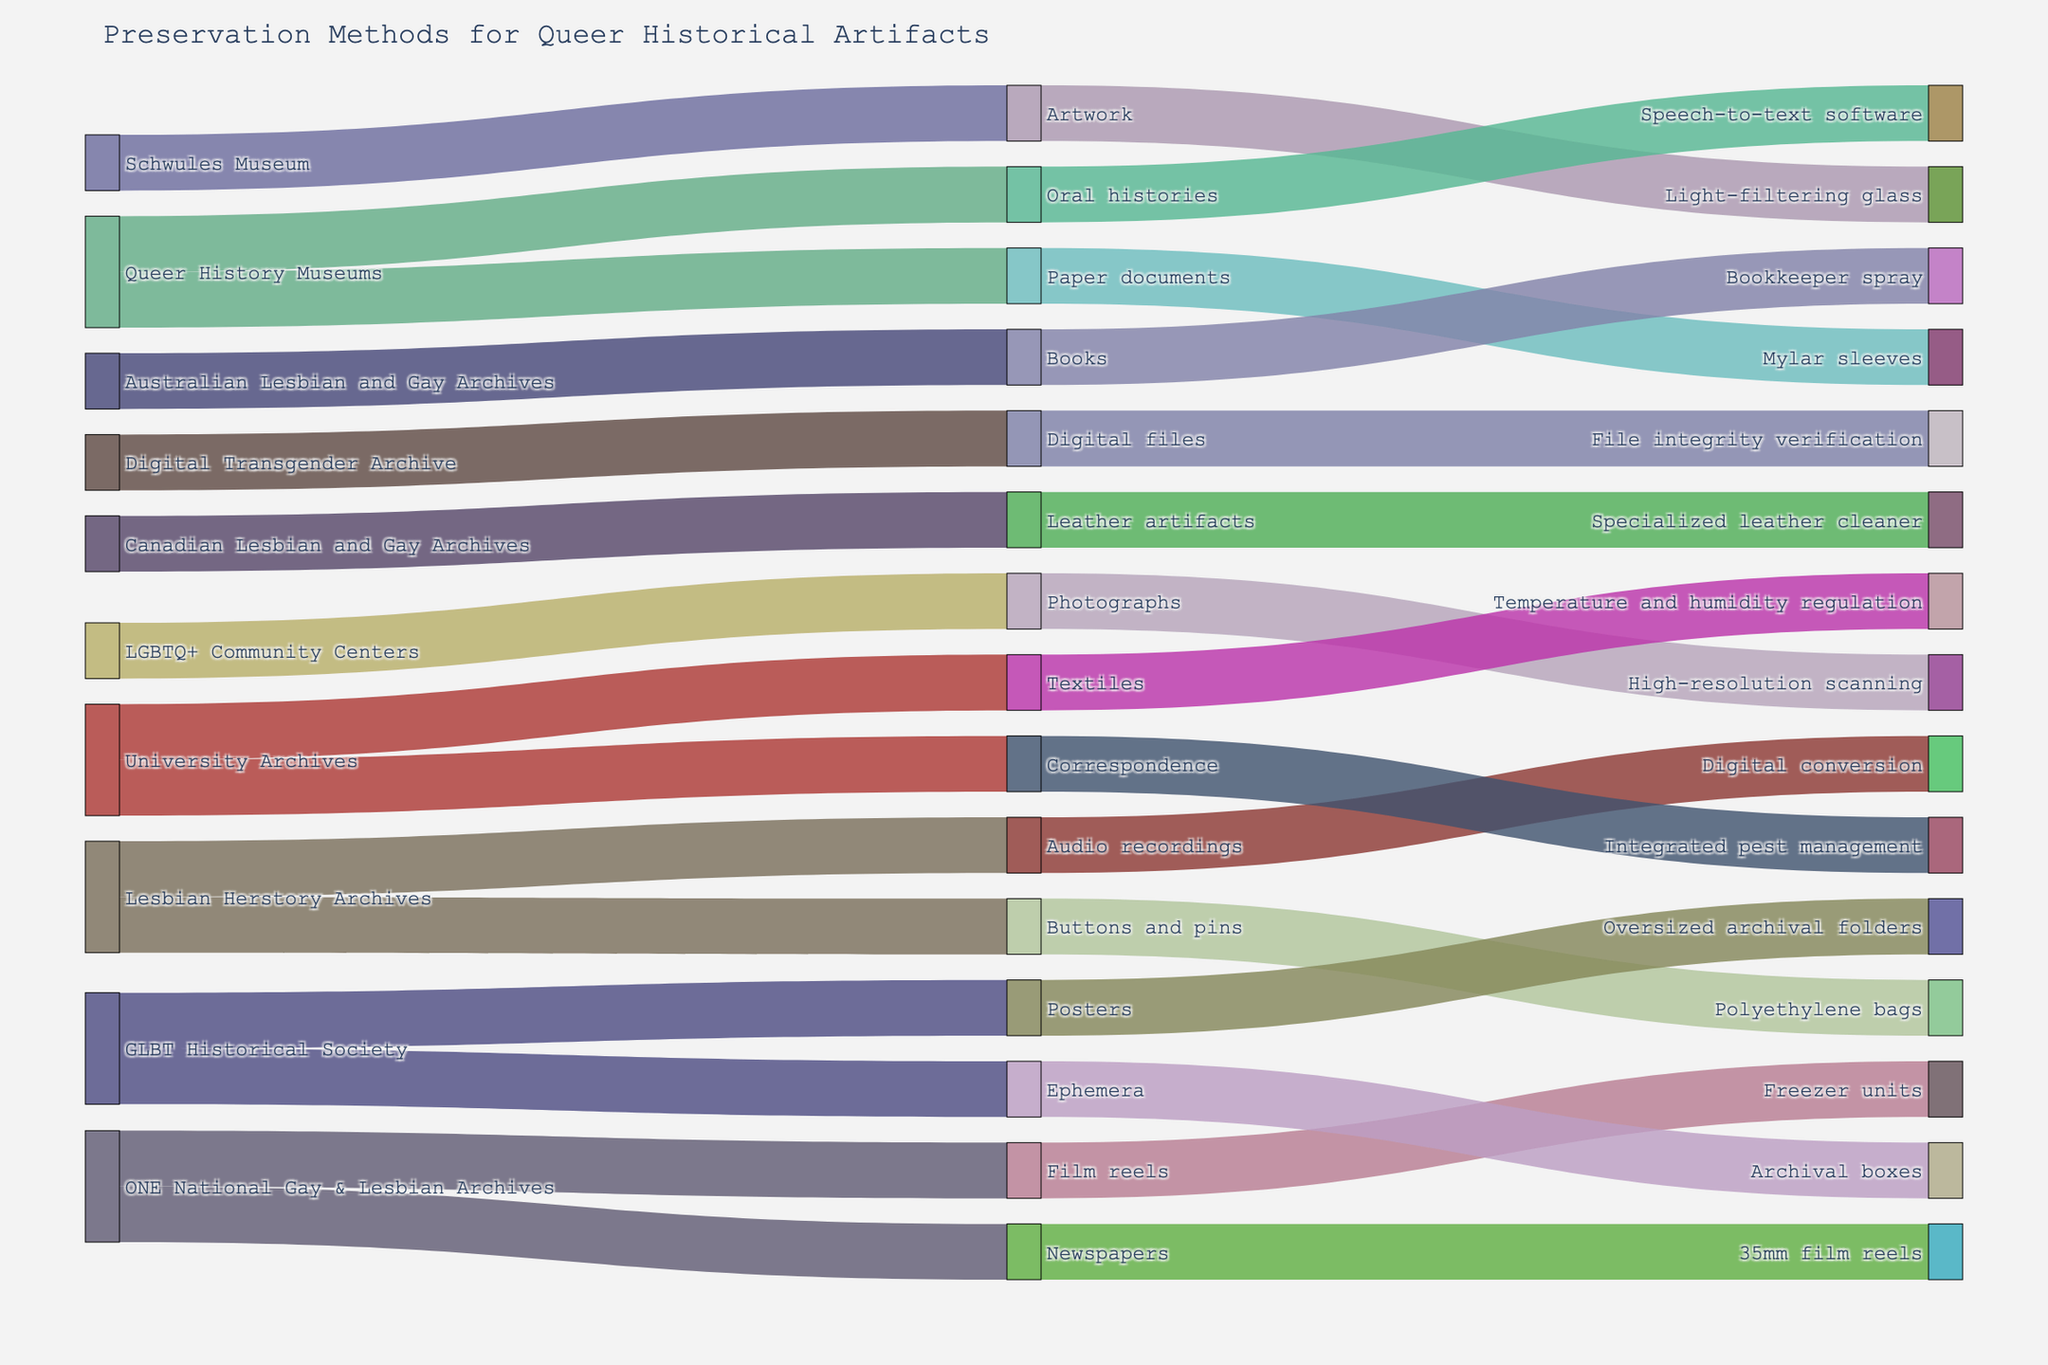What's the title of the figure? The title is usually displayed at the top of the figure. By reading the top part of this particular Sankey diagram, you would find the title displayed.
Answer: Preservation Methods for Queer Historical Artifacts Which material types are associated with digitization? To answer this, you need to look at the pathways that flow from "Digitization" to various material types. Check the links connected to "Digitization".
Answer: Photographs How many different preservation methods are depicted in the figure? To find this, count all the unique labels in the "Preservation Method" category, which are linked between material types and conservation techniques.
Answer: 5 Which source institution has the most variety of conservation techniques? Observe the institution names on the left and count the number of different conservation techniques each institution is linked to.
Answer: GLBT Historical Society What is the preservation method used for leather artifacts at the Canadian Lesbian and Gay Archives? Trace the pathway from "Canadian Lesbian and Gay Archives" to "Leather artifacts" and then to its preservation method.
Answer: Cleaning How are oral histories preserved according to the diagram? Identify the link starting from "Oral histories" and follow it to the preservation method and conservation technique.
Answer: Transcription Which material type uses high-resolution scanning? Look for "High-resolution scanning" in the conservation techniques and trace back to the connected material type.
Answer: Photographs Compare the preservation methods used by LGBTQ+ Community Centers and University Archives. How are they different? Look at the connections from "LGBTQ+ Community Centers" and "University Archives" to their respective material types, preservation methods, and conservation techniques, then compare.
Answer: LGBTQ+ Community Centers use Digitization (high-resolution scanning), while University Archives use Controlled Environment (temperature and humidity regulation) What conservation technique is paired with microfilming? Follow the link from "Microfilming" in the conservation techniques section to find the associated material type.
Answer: 35mm film reels Which sources are responsible for digitizing audio recordings? Trace the links from "Digitization" and look for those specifically tied to audio recordings.
Answer: Lesbian Herstory Archives 